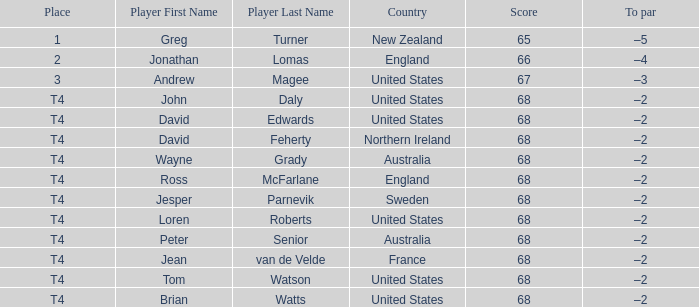Which To par has a Place of t4, and wayne grady is in? –2. 